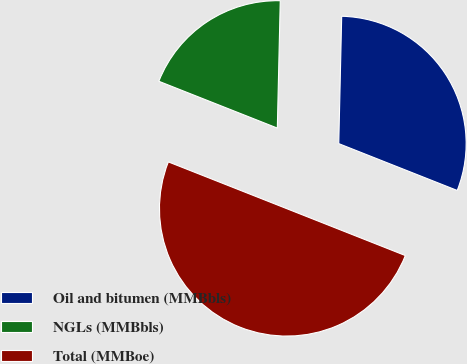Convert chart. <chart><loc_0><loc_0><loc_500><loc_500><pie_chart><fcel>Oil and bitumen (MMBbls)<fcel>NGLs (MMBbls)<fcel>Total (MMBoe)<nl><fcel>30.63%<fcel>19.38%<fcel>50.0%<nl></chart> 